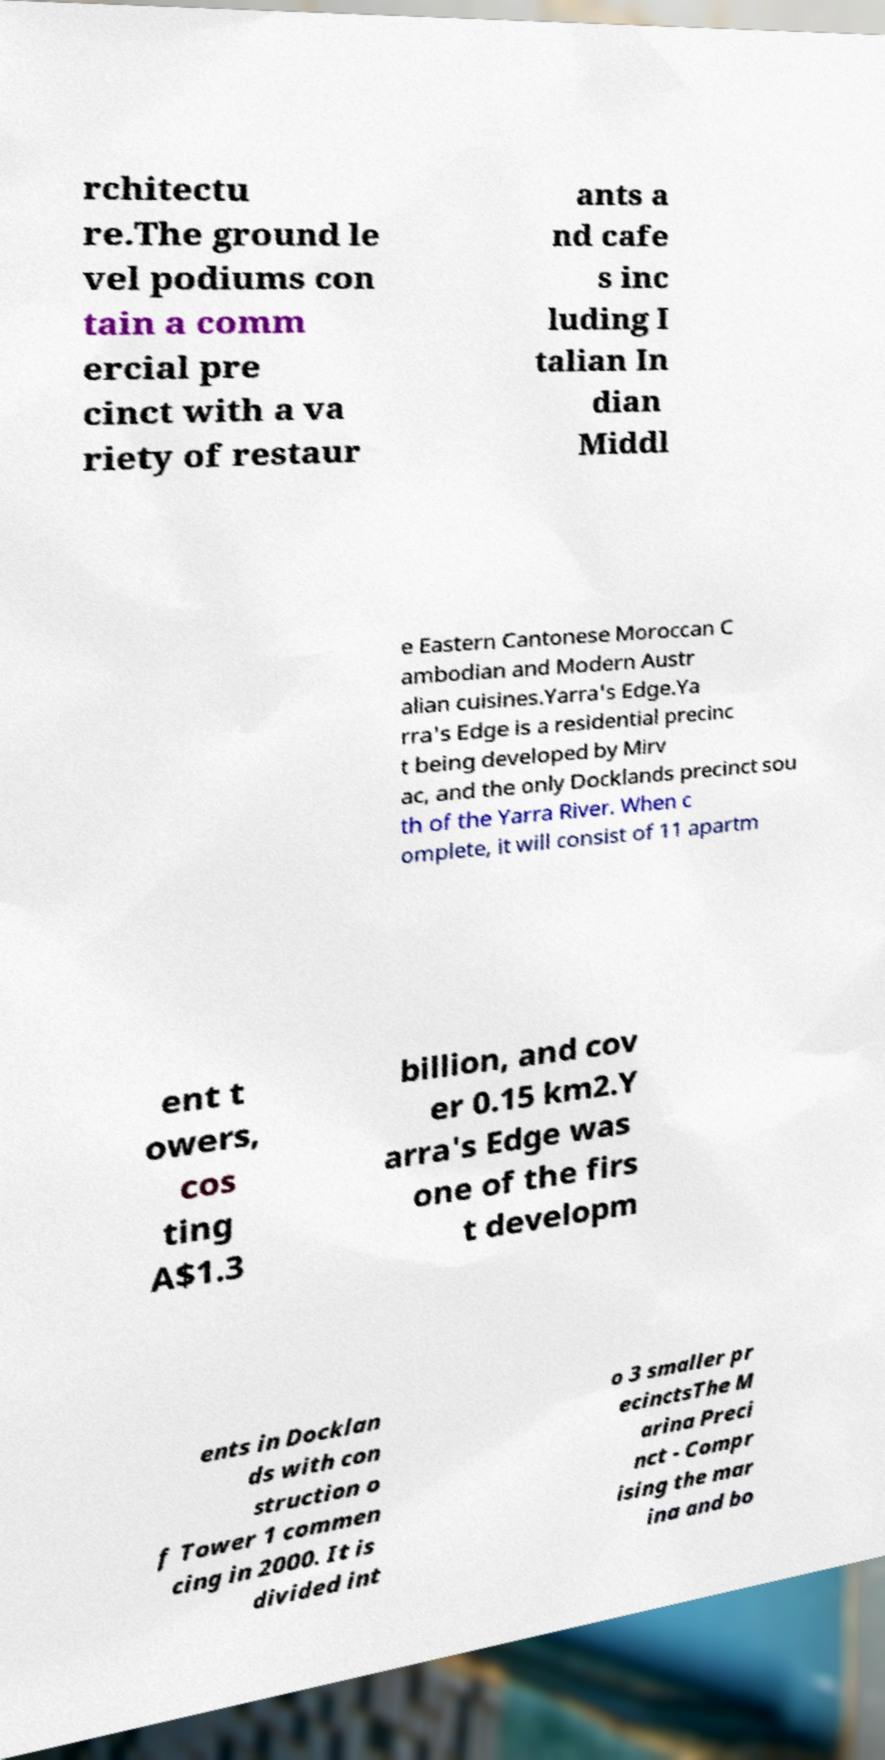Could you extract and type out the text from this image? rchitectu re.The ground le vel podiums con tain a comm ercial pre cinct with a va riety of restaur ants a nd cafe s inc luding I talian In dian Middl e Eastern Cantonese Moroccan C ambodian and Modern Austr alian cuisines.Yarra's Edge.Ya rra's Edge is a residential precinc t being developed by Mirv ac, and the only Docklands precinct sou th of the Yarra River. When c omplete, it will consist of 11 apartm ent t owers, cos ting A$1.3 billion, and cov er 0.15 km2.Y arra's Edge was one of the firs t developm ents in Docklan ds with con struction o f Tower 1 commen cing in 2000. It is divided int o 3 smaller pr ecinctsThe M arina Preci nct - Compr ising the mar ina and bo 